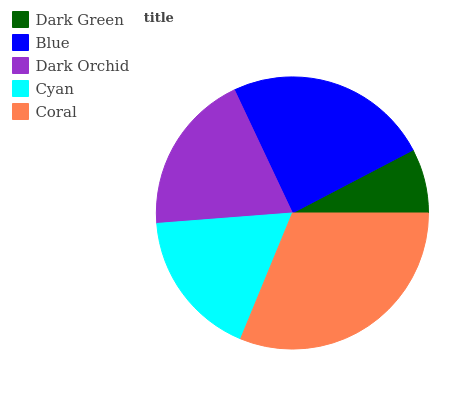Is Dark Green the minimum?
Answer yes or no. Yes. Is Coral the maximum?
Answer yes or no. Yes. Is Blue the minimum?
Answer yes or no. No. Is Blue the maximum?
Answer yes or no. No. Is Blue greater than Dark Green?
Answer yes or no. Yes. Is Dark Green less than Blue?
Answer yes or no. Yes. Is Dark Green greater than Blue?
Answer yes or no. No. Is Blue less than Dark Green?
Answer yes or no. No. Is Dark Orchid the high median?
Answer yes or no. Yes. Is Dark Orchid the low median?
Answer yes or no. Yes. Is Dark Green the high median?
Answer yes or no. No. Is Cyan the low median?
Answer yes or no. No. 